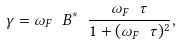<formula> <loc_0><loc_0><loc_500><loc_500>\gamma = \omega _ { F } \ B ^ { \ast } \ \frac { \omega _ { F } \ \tau } { 1 + ( \omega _ { F } \ \tau ) ^ { 2 } } ,</formula> 